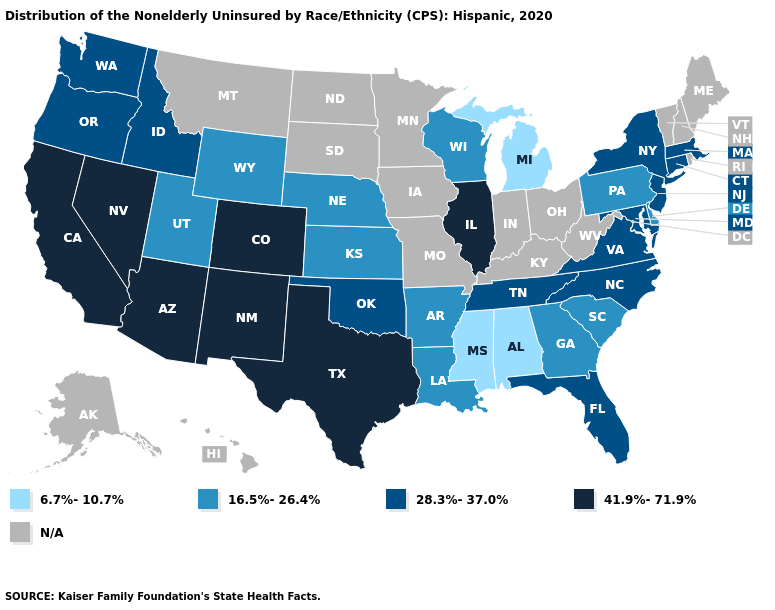What is the value of Ohio?
Answer briefly. N/A. Does Illinois have the highest value in the USA?
Be succinct. Yes. What is the highest value in the MidWest ?
Concise answer only. 41.9%-71.9%. Name the states that have a value in the range 6.7%-10.7%?
Quick response, please. Alabama, Michigan, Mississippi. Which states have the lowest value in the USA?
Answer briefly. Alabama, Michigan, Mississippi. What is the highest value in states that border California?
Short answer required. 41.9%-71.9%. Among the states that border North Carolina , does South Carolina have the highest value?
Write a very short answer. No. Does Pennsylvania have the highest value in the Northeast?
Keep it brief. No. Which states have the highest value in the USA?
Write a very short answer. Arizona, California, Colorado, Illinois, Nevada, New Mexico, Texas. What is the value of Connecticut?
Be succinct. 28.3%-37.0%. Which states hav the highest value in the Northeast?
Answer briefly. Connecticut, Massachusetts, New Jersey, New York. Name the states that have a value in the range 28.3%-37.0%?
Quick response, please. Connecticut, Florida, Idaho, Maryland, Massachusetts, New Jersey, New York, North Carolina, Oklahoma, Oregon, Tennessee, Virginia, Washington. What is the value of Texas?
Keep it brief. 41.9%-71.9%. Does New Mexico have the highest value in the USA?
Give a very brief answer. Yes. 